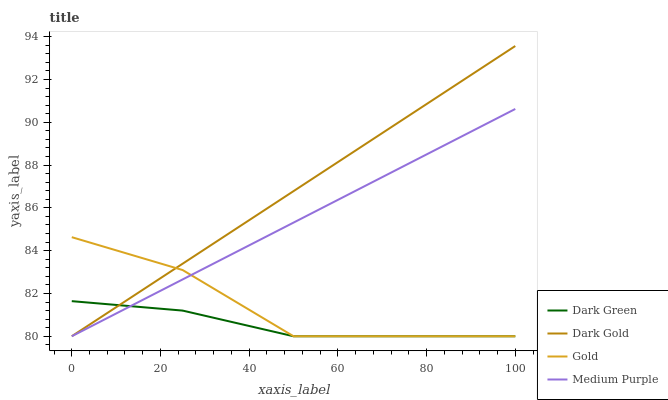Does Dark Green have the minimum area under the curve?
Answer yes or no. Yes. Does Dark Gold have the maximum area under the curve?
Answer yes or no. Yes. Does Gold have the minimum area under the curve?
Answer yes or no. No. Does Gold have the maximum area under the curve?
Answer yes or no. No. Is Medium Purple the smoothest?
Answer yes or no. Yes. Is Gold the roughest?
Answer yes or no. Yes. Is Dark Gold the smoothest?
Answer yes or no. No. Is Dark Gold the roughest?
Answer yes or no. No. Does Medium Purple have the lowest value?
Answer yes or no. Yes. Does Dark Gold have the highest value?
Answer yes or no. Yes. Does Gold have the highest value?
Answer yes or no. No. Does Dark Gold intersect Medium Purple?
Answer yes or no. Yes. Is Dark Gold less than Medium Purple?
Answer yes or no. No. Is Dark Gold greater than Medium Purple?
Answer yes or no. No. 